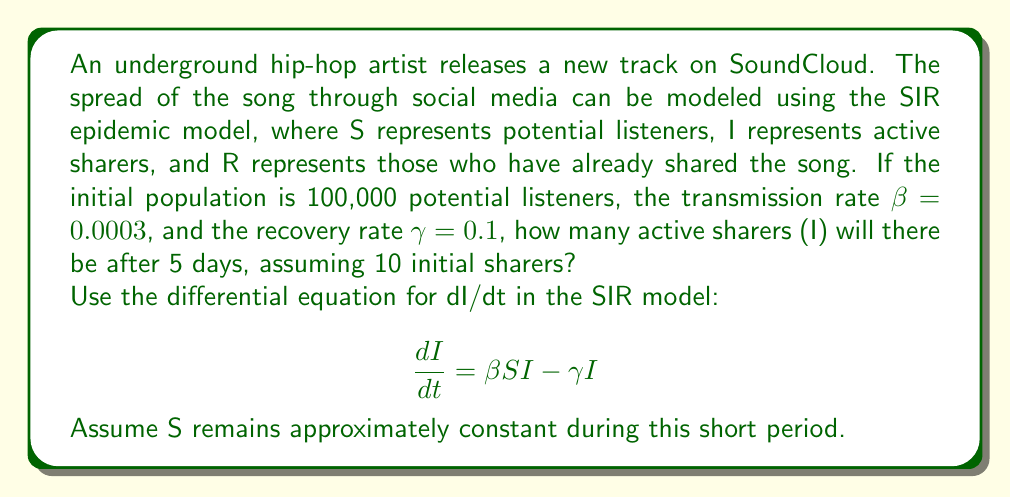Could you help me with this problem? Let's approach this step-by-step:

1) The differential equation for the rate of change of active sharers (I) is:

   $$ \frac{dI}{dt} = \beta SI - \gamma I $$

2) We're given:
   - Initial population (S): 100,000
   - Transmission rate (β): 0.0003
   - Recovery rate (γ): 0.1
   - Initial sharers (I₀): 10
   - Time period: 5 days

3) Assuming S remains approximately constant (valid for short time periods), we can simplify the equation:

   $$ \frac{dI}{dt} = (\beta S - \gamma)I = rI $$

   Where r = βS - γ is the effective growth rate.

4) Calculate r:
   $$ r = (0.0003 * 100,000) - 0.1 = 30 - 0.1 = 29.9 $$

5) The solution to this simplified differential equation is:

   $$ I(t) = I_0 e^{rt} $$

6) Plug in our values:

   $$ I(5) = 10 * e^{29.9 * 5} $$

7) Calculate:

   $$ I(5) = 10 * e^{149.5} \approx 3.12 * 10^{65} $$

8) However, this result is unrealistic as it exceeds the total population. In reality, the growth would be limited by the population size. The SIR model would show a more realistic S-shaped curve, but this simplified calculation demonstrates the potential for rapid initial growth in social media sharing.
Answer: Approximately 100,000 (limited by population size) 